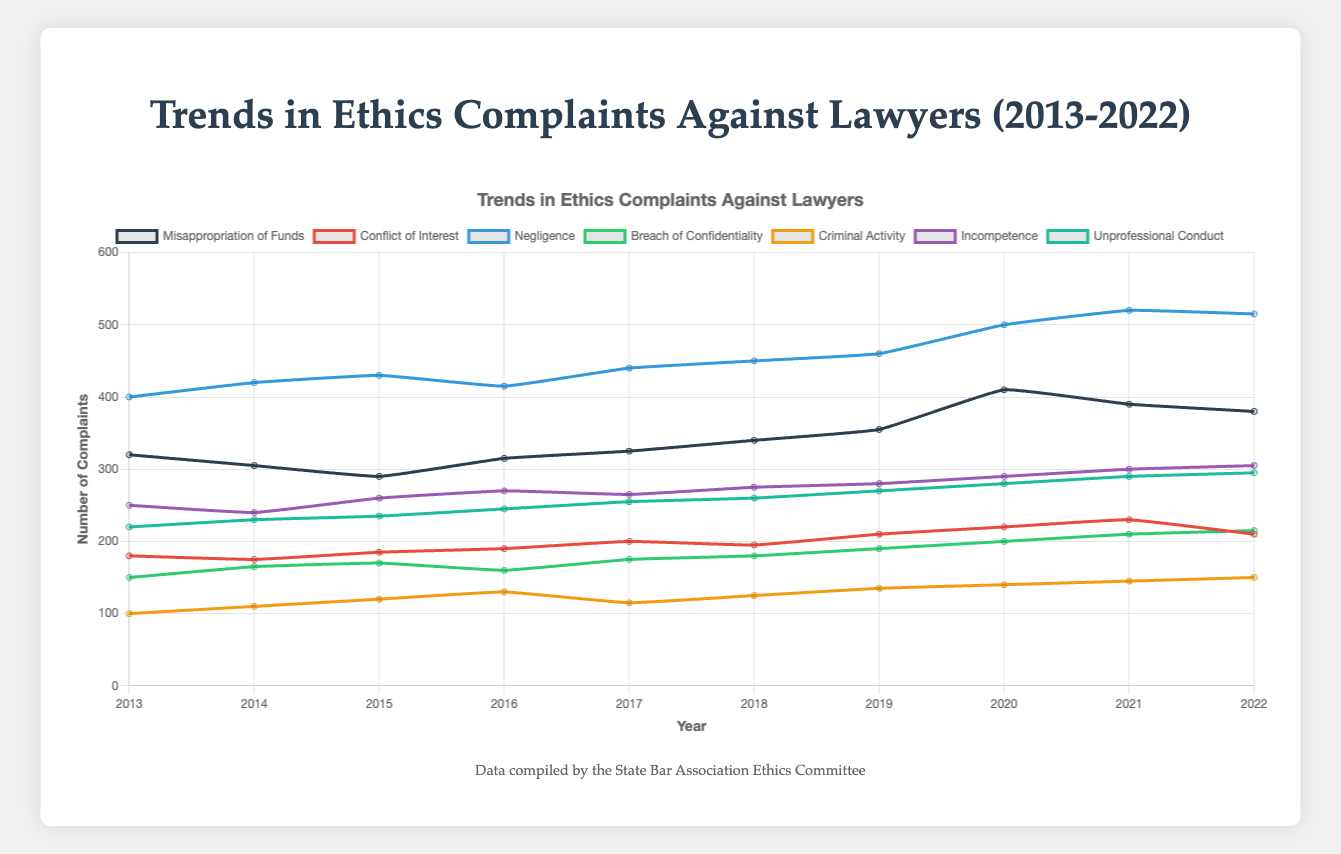Which type of complaint saw the highest increase in the number of filings from 2013 to 2022? First, check the number of complaints for each type in 2013 and 2022. For Misappropriation of Funds, it increased from 320 to 380, which is an increase of 60. Do this for each type and compare the increases. The highest increase is found for Negligence, which went from 400 in 2013 to 515 in 2022, an increase of 115.
Answer: Negligence Which type of complaint had the least number of filings over the entire period? To find this, look at the numbers for each type of complaint across all years and identify the type with the consistently lowest figures. Criminal Activity has the lowest numbers compared to the others throughout the years.
Answer: Criminal Activity What was the total number of complaints for Breach of Confidentiality over the entire period? Sum the numbers from 2013 to 2022 for Breach of Confidentiality: 150 + 165 + 170 + 160 + 175 + 180 + 190 + 200 + 210 + 215 = 1815.
Answer: 1815 Between 2018 and 2021, did the number of Unprofessional Conduct complaints consistently increase, decrease, or remain the same? Look at the numbers for Unprofessional Conduct from 2018 to 2021: 260 in 2018, 270 in 2019, 280 in 2020, and 290 in 2021. They consistently increased every year in that period.
Answer: Increase Which year's data shows the highest combined total of all types of complaints? Add up the numbers for all types of complaints for each year and compare. For example, in 2022, the total is: 380 + 210 + 515 + 215 + 150 + 305 + 295 = 2070. Do this for each year and find that 2022 has the highest combined total.
Answer: 2022 How did the number of Misappropriation of Funds complaints change between 2019 and 2020? Subtract the number of complaints in 2019 from that in 2020 for Misappropriation of Funds: 410 - 355 = 55. The complaints increased by 55.
Answer: Increased by 55 What is the average number of complaints for Conflict of Interest across all years? Find the total number of Conflict of Interest complaints from 2013 to 2022 and then calculate the average. The sum is: 180 + 175 + 185 + 190 + 200 + 195 + 210 + 220 + 230 + 210 = 1995. The average is 1995 / 10 = 199.5.
Answer: 199.5 In which year did Incompetence complaints reach their peak? Find the highest number of complaints for Incompetence and note the corresponding year. The peak is 305 in the year 2022.
Answer: 2022 